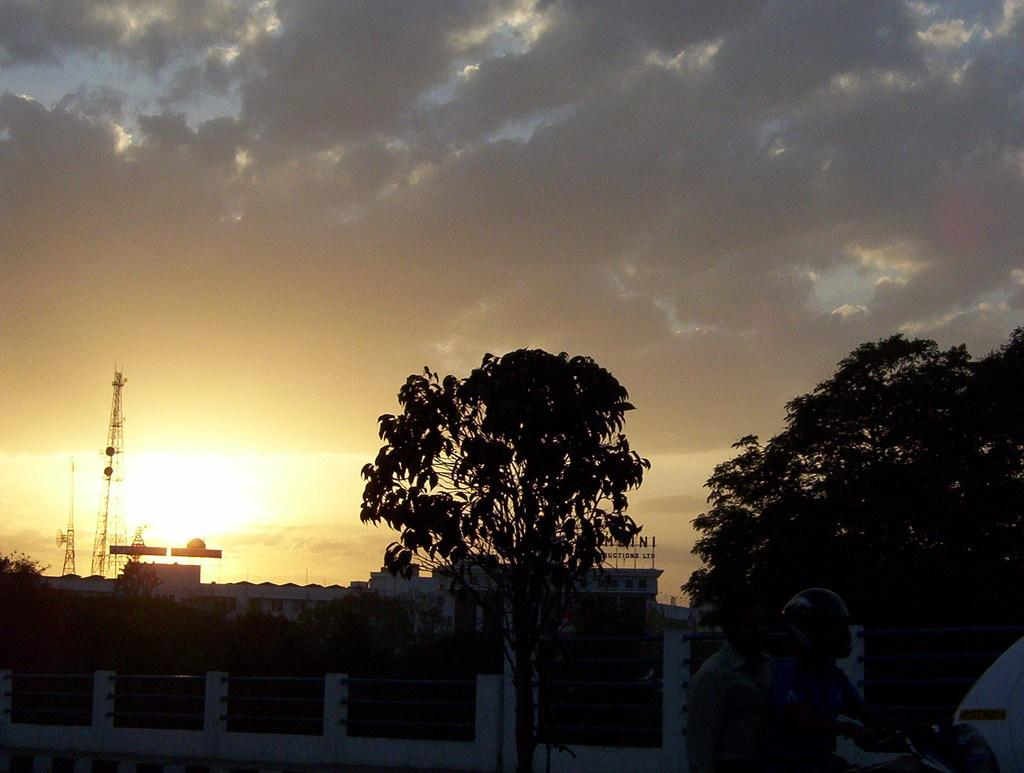What can be seen in the foreground of the image? There is a railing with poles in the foreground of the image. What are the two persons in the image doing? They are on a motorcycle. Which person is wearing protective gear? One person is wearing a helmet. What can be seen in the background of the image? There are trees, buildings, towers, and the sky visible in the background of the image. What is the weather like in the image? The presence of clouds in the sky suggests that it might be partly cloudy. Where is the pot located in the image? There is no pot present in the image. Can you describe the cave in the image? There is no cave present in the image. 